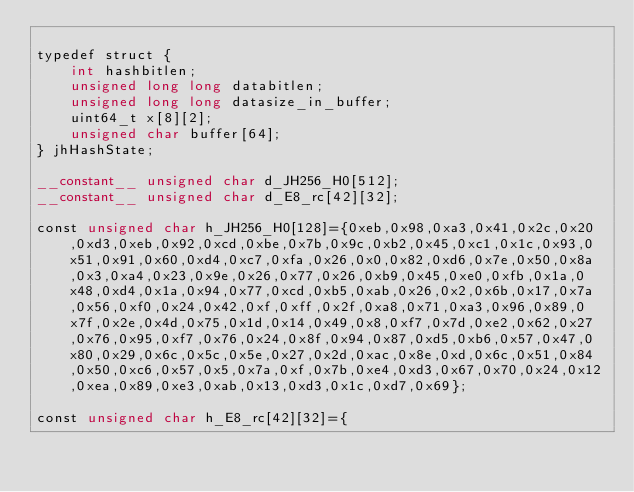Convert code to text. <code><loc_0><loc_0><loc_500><loc_500><_Cuda_>
typedef struct {
	int hashbitlen;
	unsigned long long databitlen;
	unsigned long long datasize_in_buffer;
	uint64_t x[8][2];
	unsigned char buffer[64];
} jhHashState;

__constant__ unsigned char d_JH256_H0[512];
__constant__ unsigned char d_E8_rc[42][32];

const unsigned char h_JH256_H0[128]={0xeb,0x98,0xa3,0x41,0x2c,0x20,0xd3,0xeb,0x92,0xcd,0xbe,0x7b,0x9c,0xb2,0x45,0xc1,0x1c,0x93,0x51,0x91,0x60,0xd4,0xc7,0xfa,0x26,0x0,0x82,0xd6,0x7e,0x50,0x8a,0x3,0xa4,0x23,0x9e,0x26,0x77,0x26,0xb9,0x45,0xe0,0xfb,0x1a,0x48,0xd4,0x1a,0x94,0x77,0xcd,0xb5,0xab,0x26,0x2,0x6b,0x17,0x7a,0x56,0xf0,0x24,0x42,0xf,0xff,0x2f,0xa8,0x71,0xa3,0x96,0x89,0x7f,0x2e,0x4d,0x75,0x1d,0x14,0x49,0x8,0xf7,0x7d,0xe2,0x62,0x27,0x76,0x95,0xf7,0x76,0x24,0x8f,0x94,0x87,0xd5,0xb6,0x57,0x47,0x80,0x29,0x6c,0x5c,0x5e,0x27,0x2d,0xac,0x8e,0xd,0x6c,0x51,0x84,0x50,0xc6,0x57,0x5,0x7a,0xf,0x7b,0xe4,0xd3,0x67,0x70,0x24,0x12,0xea,0x89,0xe3,0xab,0x13,0xd3,0x1c,0xd7,0x69};

const unsigned char h_E8_rc[42][32]={</code> 